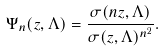Convert formula to latex. <formula><loc_0><loc_0><loc_500><loc_500>\Psi _ { n } ( z , \Lambda ) = \frac { \sigma ( n z , \Lambda ) } { \sigma ( z , \Lambda ) ^ { n ^ { 2 } } } .</formula> 